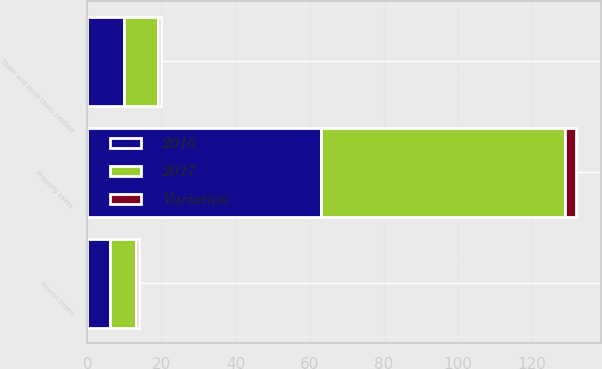Convert chart. <chart><loc_0><loc_0><loc_500><loc_500><stacked_bar_chart><ecel><fcel>Property taxes<fcel>State and local taxes related<fcel>Payroll taxes<nl><fcel>2017<fcel>66<fcel>9<fcel>7<nl><fcel>2016<fcel>63<fcel>10<fcel>6<nl><fcel>Variation<fcel>3<fcel>1<fcel>1<nl></chart> 